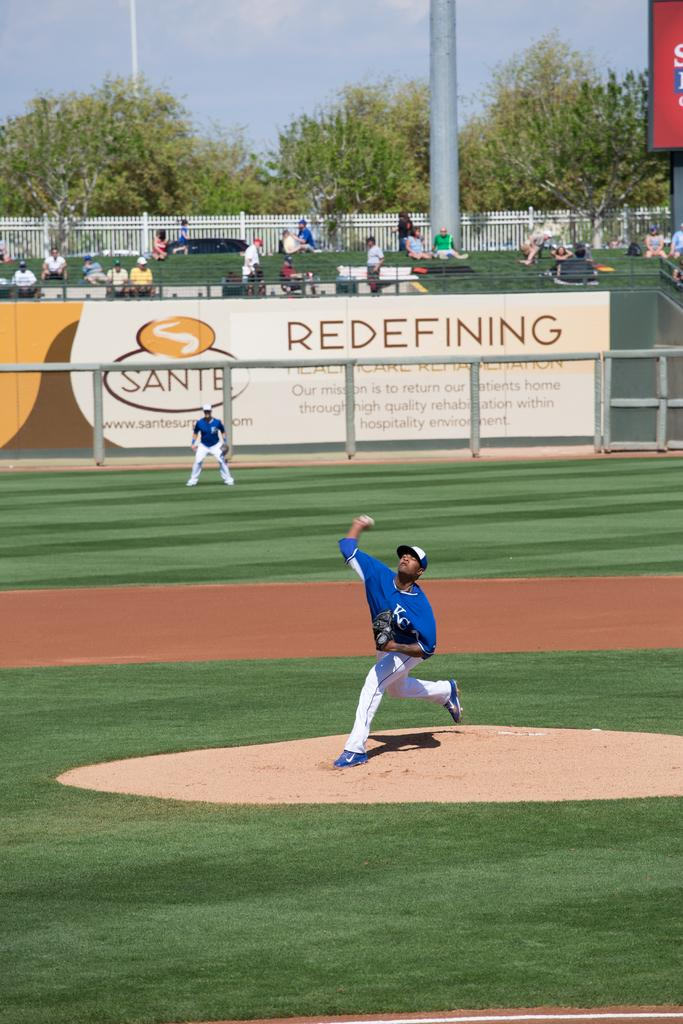Provide a one-sentence caption for the provided image. a pitcher throwing a ball and a sign that says redefining in the outfield. 